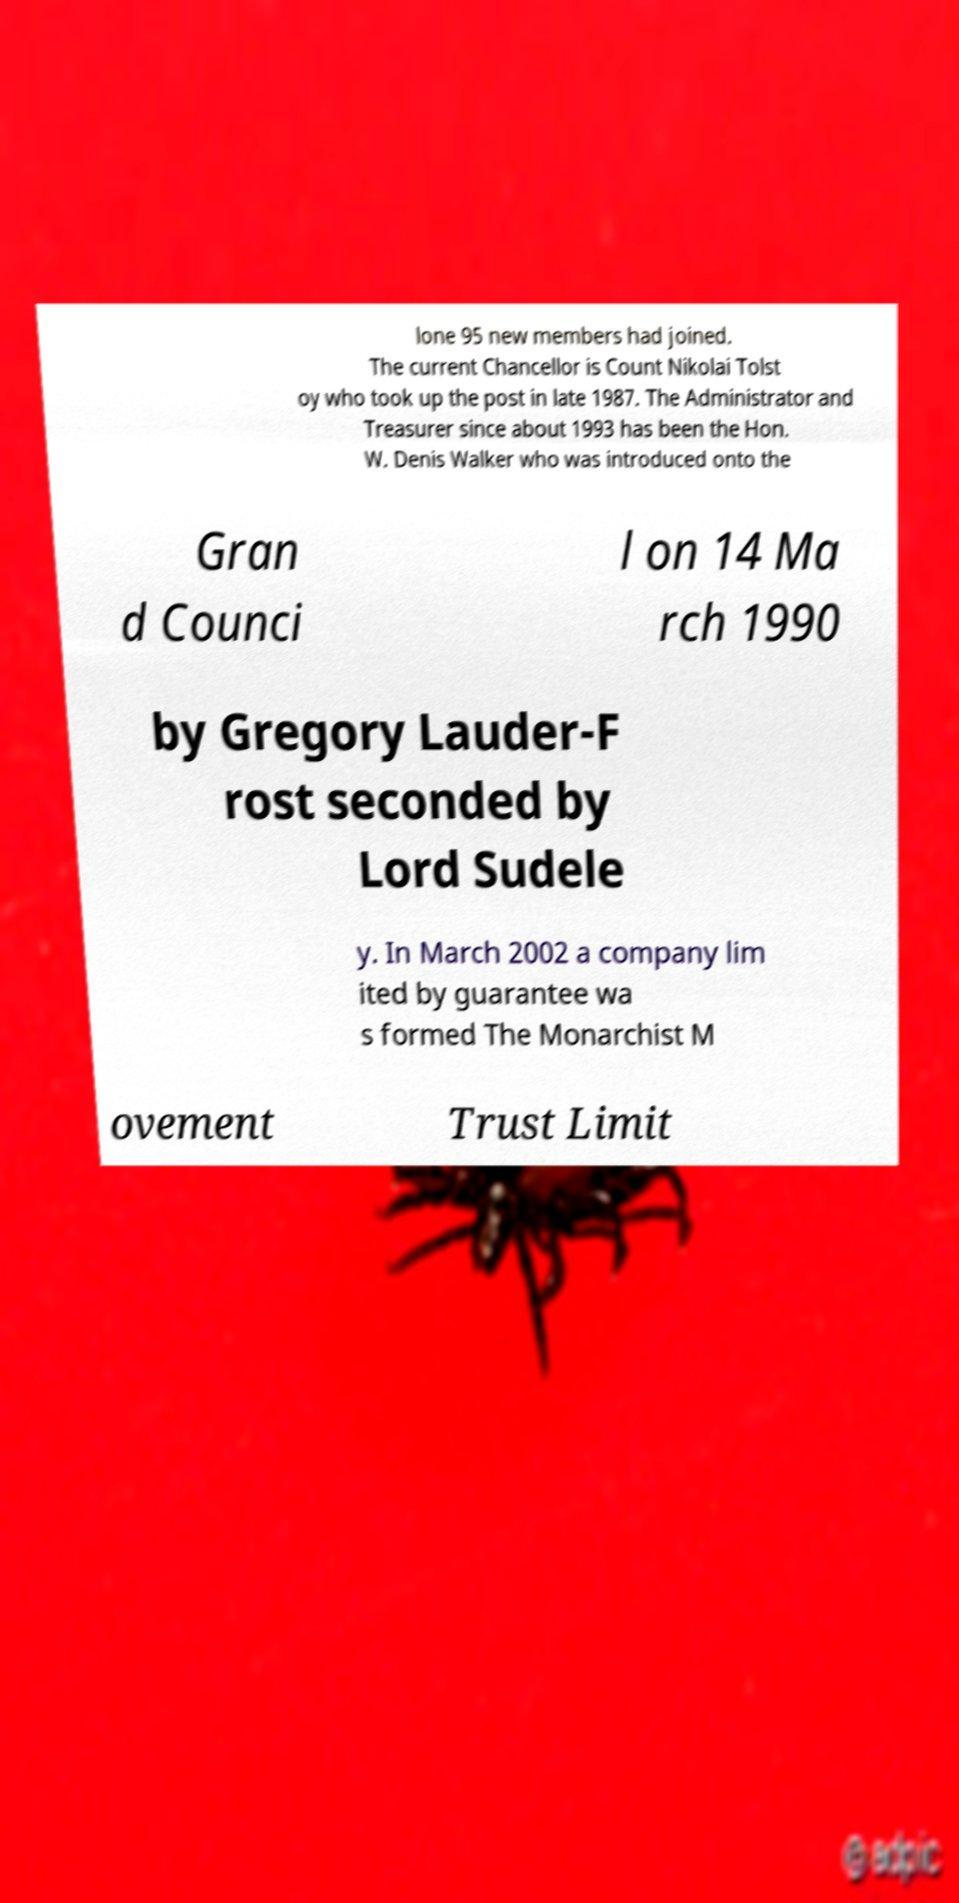Could you extract and type out the text from this image? lone 95 new members had joined. The current Chancellor is Count Nikolai Tolst oy who took up the post in late 1987. The Administrator and Treasurer since about 1993 has been the Hon. W. Denis Walker who was introduced onto the Gran d Counci l on 14 Ma rch 1990 by Gregory Lauder-F rost seconded by Lord Sudele y. In March 2002 a company lim ited by guarantee wa s formed The Monarchist M ovement Trust Limit 